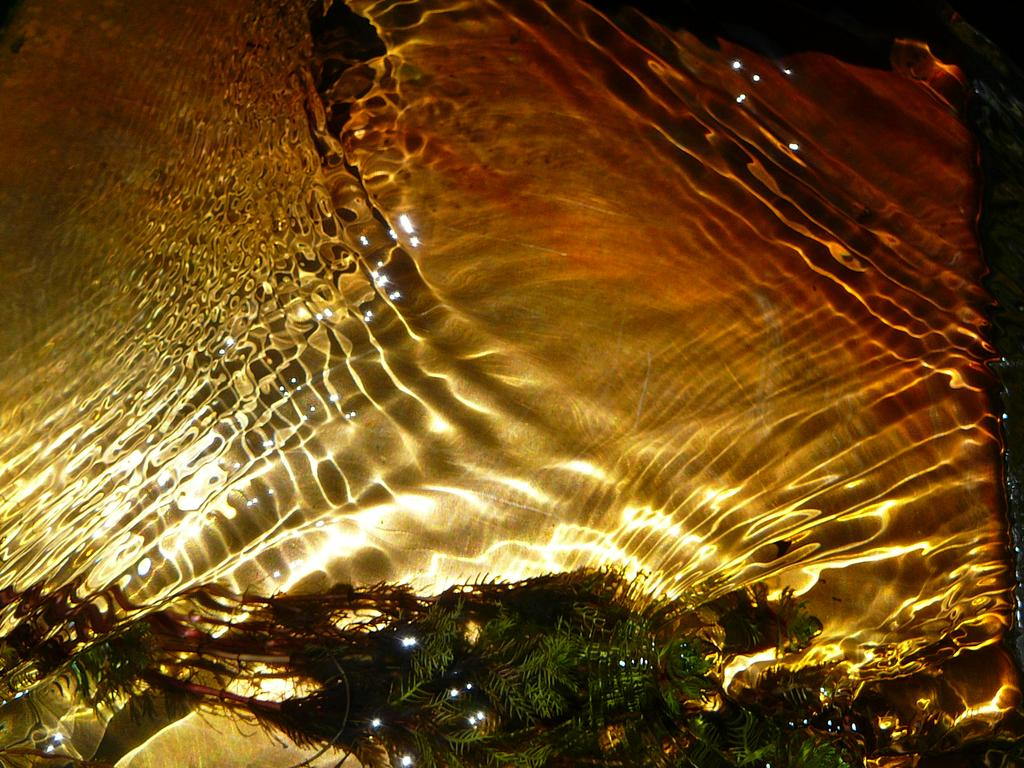What is happening in the image? There is water flowing in the image. Can you describe any objects or organisms in the water? There is a plant visible in the water. What type of silver can be seen in the image? There is no silver present in the image; it features water flowing with a plant visible in it. How does the robin interact with the water in the image? There is no robin present in the image; it only features water and a plant. 